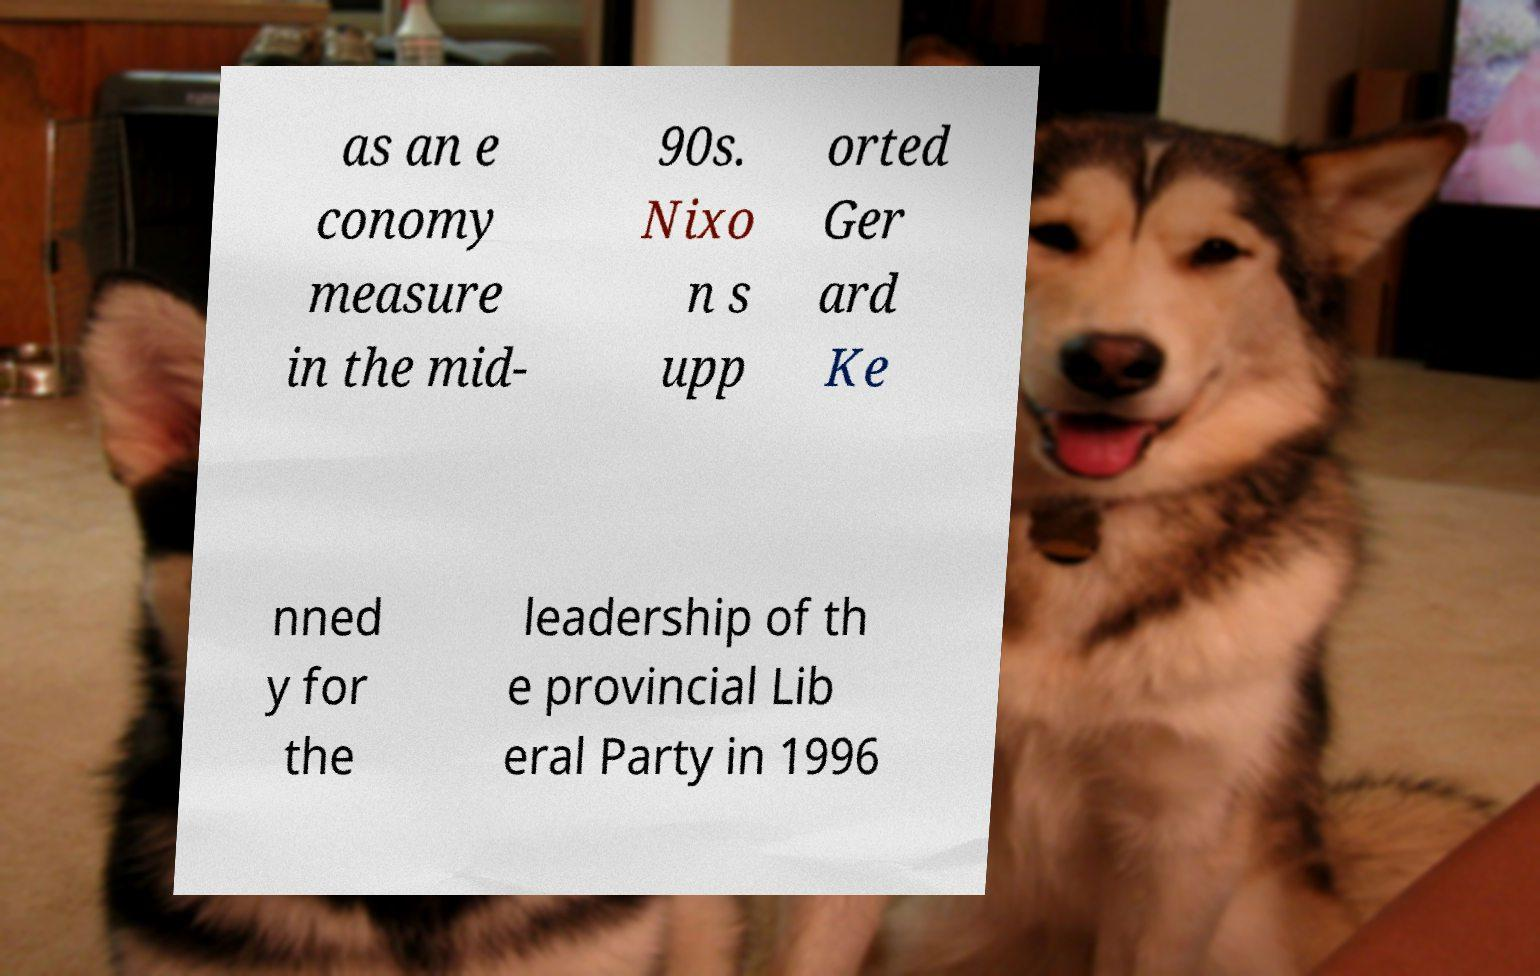Could you extract and type out the text from this image? as an e conomy measure in the mid- 90s. Nixo n s upp orted Ger ard Ke nned y for the leadership of th e provincial Lib eral Party in 1996 